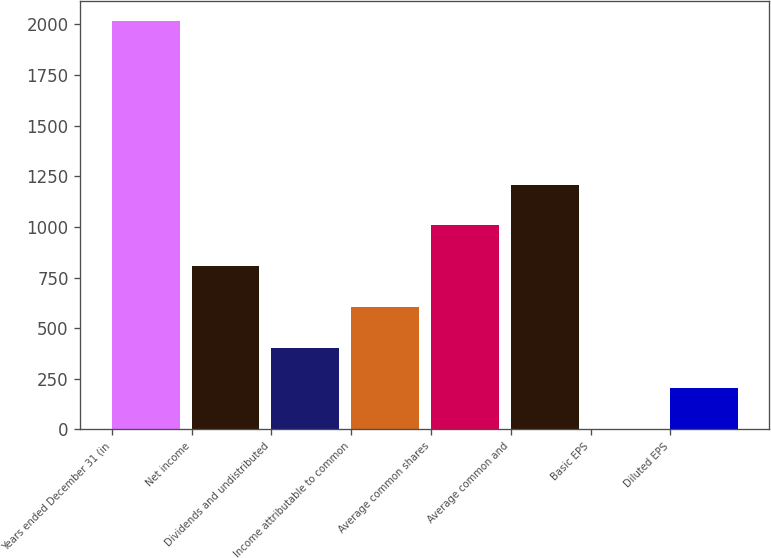Convert chart. <chart><loc_0><loc_0><loc_500><loc_500><bar_chart><fcel>Years ended December 31 (in<fcel>Net income<fcel>Dividends and undistributed<fcel>Income attributable to common<fcel>Average common shares<fcel>Average common and<fcel>Basic EPS<fcel>Diluted EPS<nl><fcel>2015<fcel>806.5<fcel>403.68<fcel>605.09<fcel>1007.91<fcel>1209.32<fcel>0.86<fcel>202.27<nl></chart> 